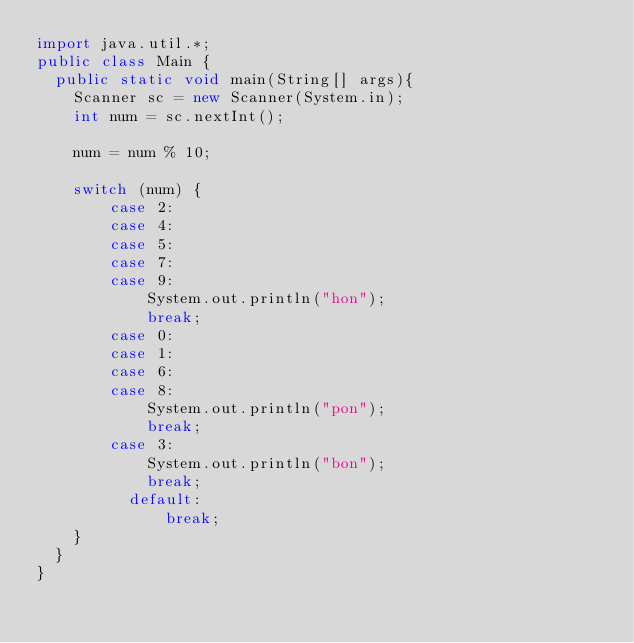Convert code to text. <code><loc_0><loc_0><loc_500><loc_500><_Java_>import java.util.*;
public class Main {
	public static void main(String[] args){
		Scanner sc = new Scanner(System.in);
		int num = sc.nextInt();
		
		num = num % 10;
		
		switch (num) {
		    case 2:
		    case 4:
		    case 5:
		    case 7:
		    case 9:
		        System.out.println("hon");
		        break;
		    case 0:
		    case 1:
		    case 6:
		    case 8:
		        System.out.println("pon");
		        break;
		    case 3:
		        System.out.println("bon");
		        break;
	        default:
	            break;
		}
	}
}</code> 